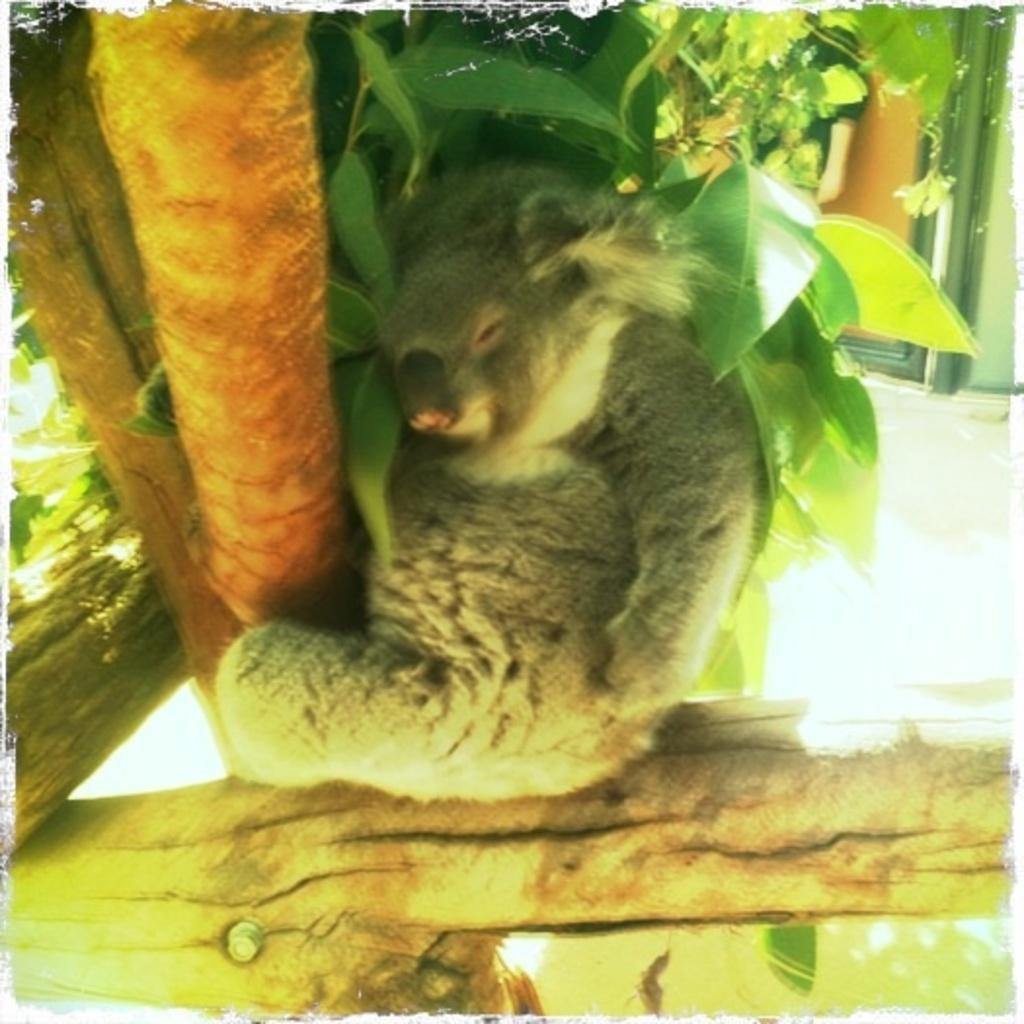What type of animal is in the image? The type of animal cannot be determined from the provided facts. What natural element is present in the image? There is a tree in the image. What architectural feature can be seen in the background of the image? There appears to be a door in the background of the image. What type of surface is visible at the bottom of the image? There is a floor at the bottom of the image. What other structural element is visible in the background of the image? There is a wall visible in the background of the image. What type of writing can be seen on the wall in the image? There is no writing visible on the wall in the image. What angle is the animal positioned at in the image? The angle at which the animal is positioned cannot be determined from the provided facts. 